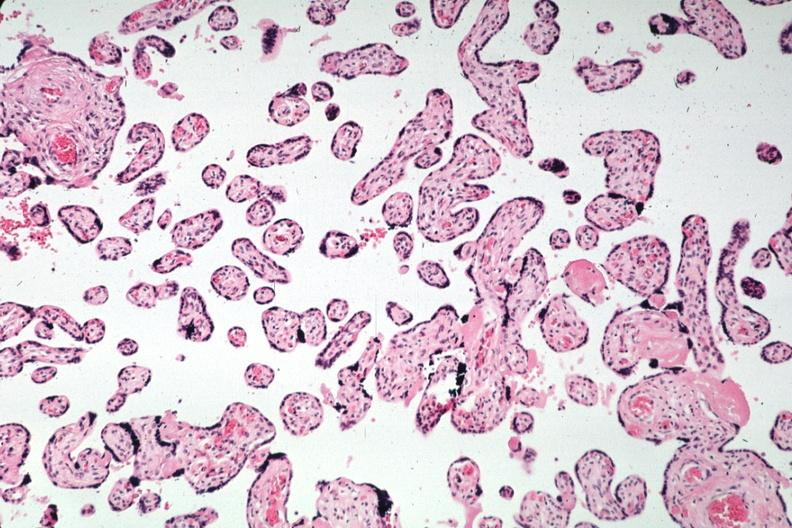s female reproductive present?
Answer the question using a single word or phrase. Yes 